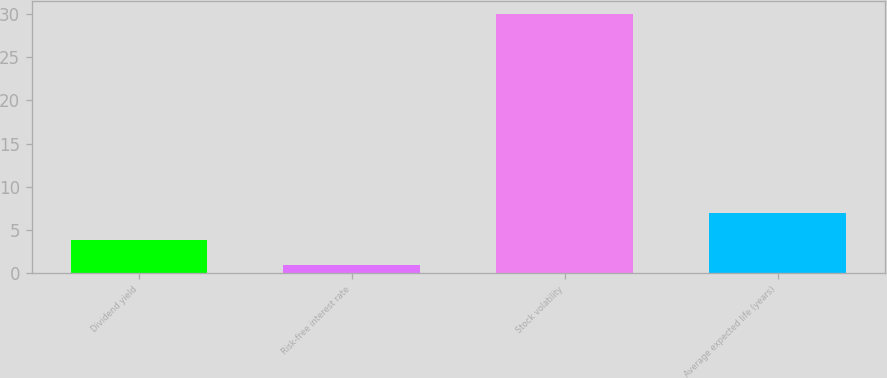Convert chart. <chart><loc_0><loc_0><loc_500><loc_500><bar_chart><fcel>Dividend yield<fcel>Risk-free interest rate<fcel>Stock volatility<fcel>Average expected life (years)<nl><fcel>3.9<fcel>1<fcel>30<fcel>7<nl></chart> 